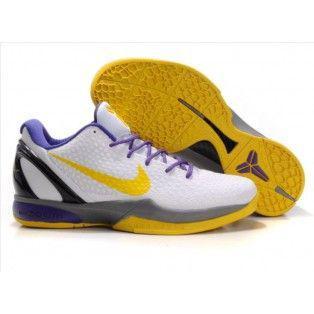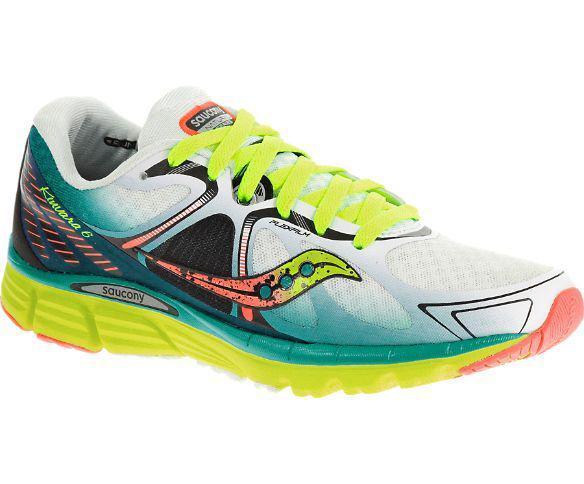The first image is the image on the left, the second image is the image on the right. For the images displayed, is the sentence "A pair of shoes are on the right side." factually correct? Answer yes or no. No. 